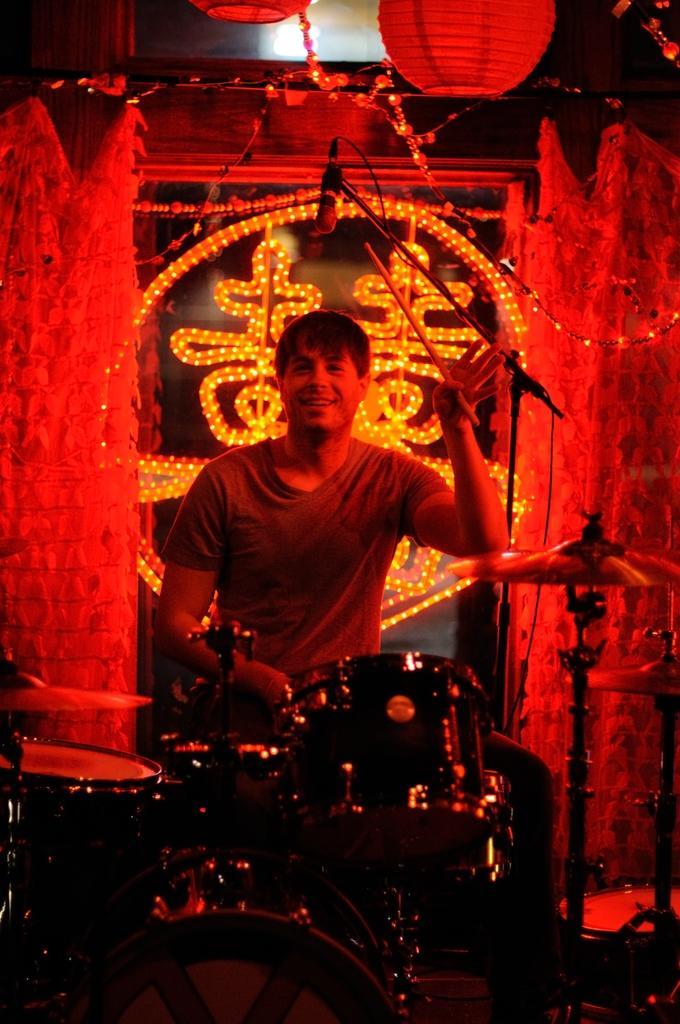In one or two sentences, can you explain what this image depicts? In this image I can see in the middle a man is beating the drums, he wear a t-shirt. Behind him there are lights, at the top there is the microphone. 